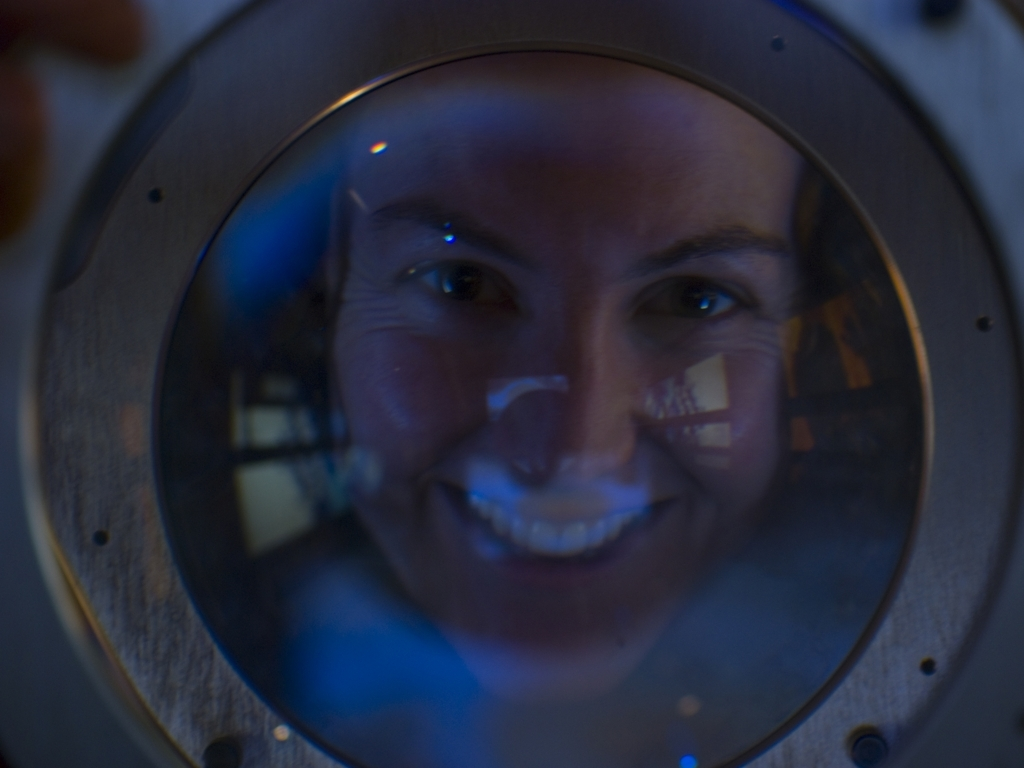Can you describe the mood or atmosphere this image conveys? The image conveys a sense of curiosity and wonder, as the subject's facial expression is cheerful and engaging. The use of cool blue tones and the mysterious, circular framing gives it a somewhat futuristic and scientific atmosphere. Could the image be part of a larger narrative or story? Certainly, this image could be a snapshot from a narrative revolving around discovery, science, or exploration. The subject's expression and the context created by the circular frame can suggest a moment of a breakthrough or a gaze into a new world. 